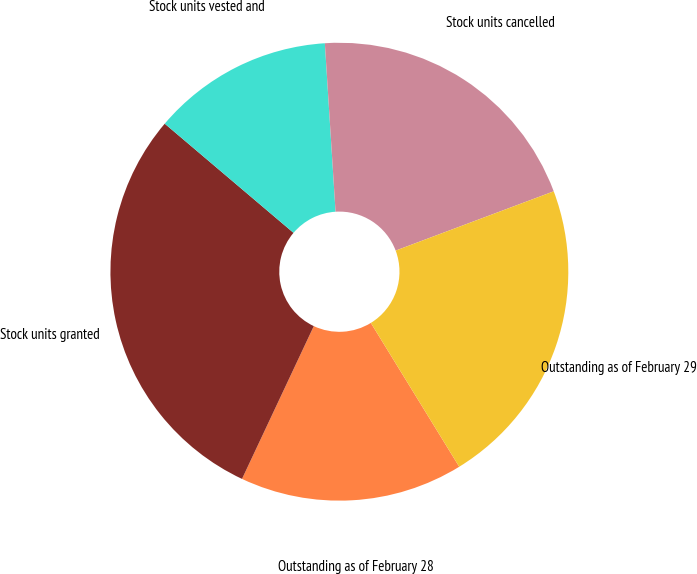Convert chart to OTSL. <chart><loc_0><loc_0><loc_500><loc_500><pie_chart><fcel>Outstanding as of February 28<fcel>Stock units granted<fcel>Stock units vested and<fcel>Stock units cancelled<fcel>Outstanding as of February 29<nl><fcel>15.76%<fcel>29.2%<fcel>12.8%<fcel>20.3%<fcel>21.94%<nl></chart> 